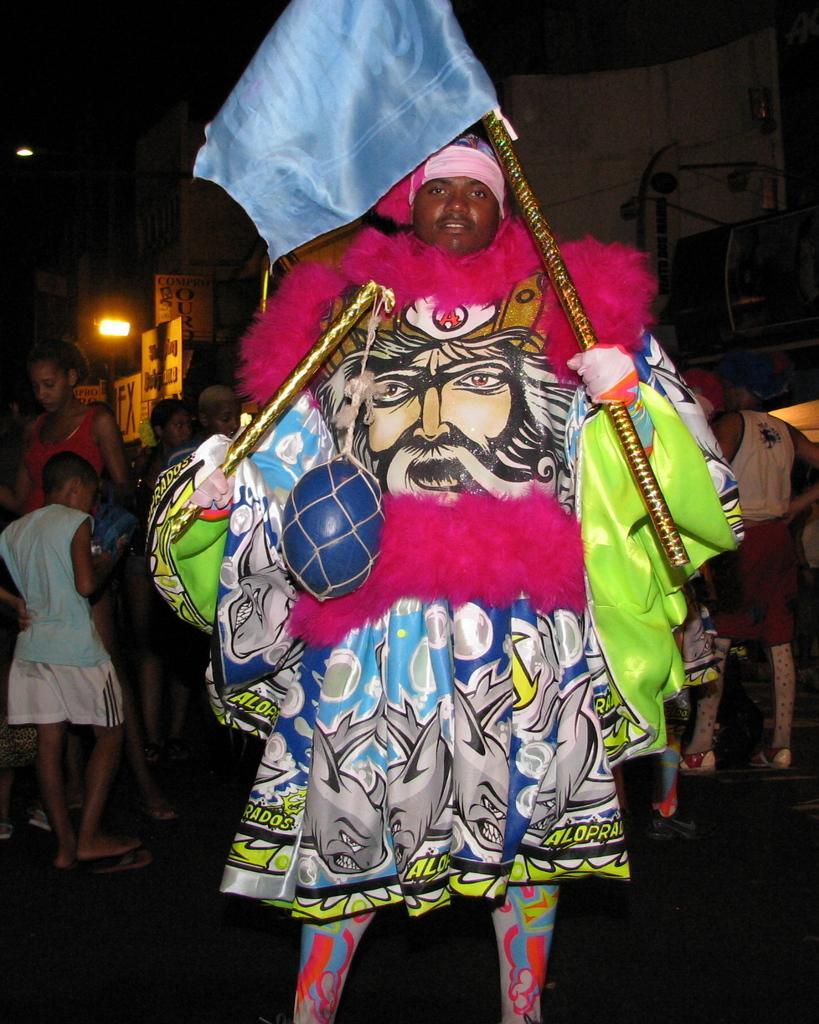Please provide a concise description of this image. In this image, we can see a person is wearing colorful costumes and holding sticks. Here we can see balloon and flag. Background we can see a group of people, houses, hoardings, lights, banners. 